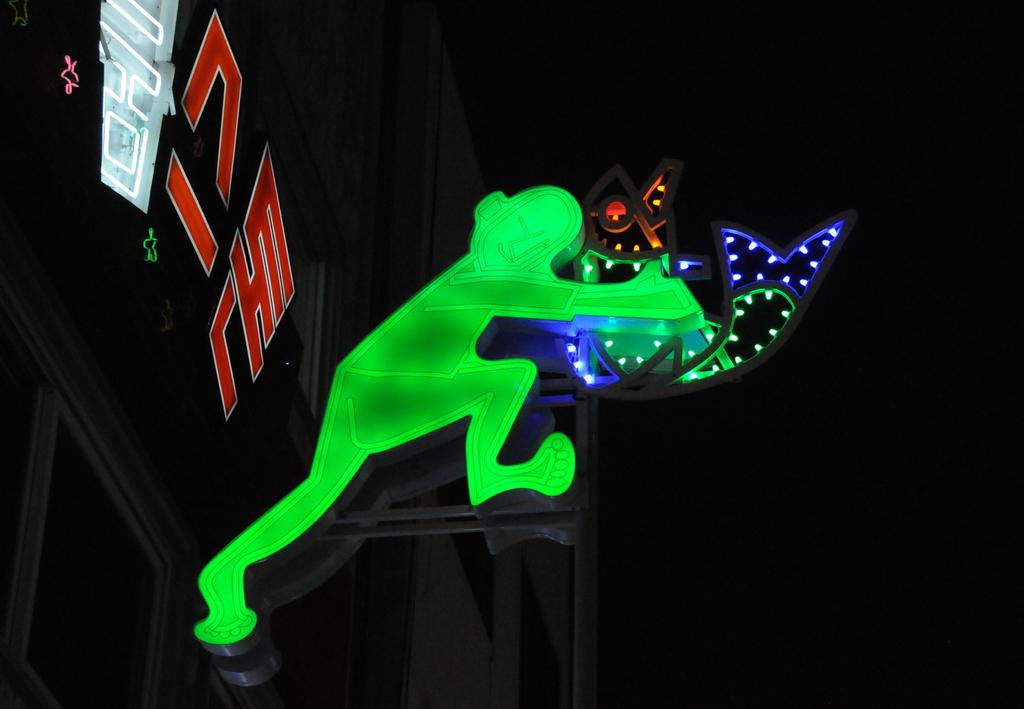What is the main structure visible in the image? There is a building in the image. Can you describe the person in front of the building? The person is standing in front of the building. What is the person holding in the image? The person is holding an object. What type of reward is the person receiving for solving the riddle in the image? There is no indication in the image that the person is solving a riddle or receiving a reward. 